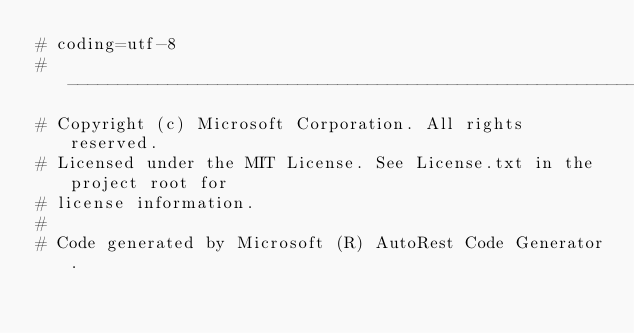Convert code to text. <code><loc_0><loc_0><loc_500><loc_500><_Python_># coding=utf-8
# --------------------------------------------------------------------------
# Copyright (c) Microsoft Corporation. All rights reserved.
# Licensed under the MIT License. See License.txt in the project root for
# license information.
#
# Code generated by Microsoft (R) AutoRest Code Generator.</code> 